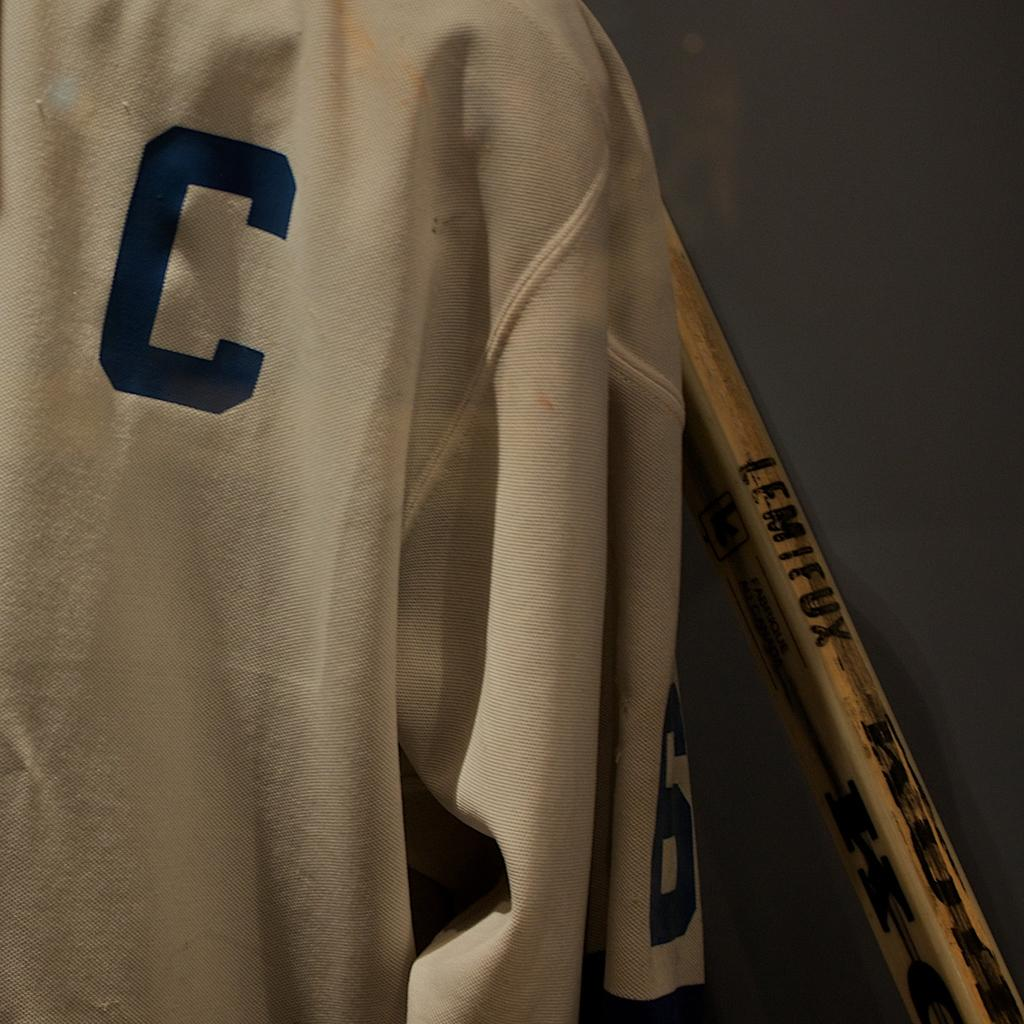Provide a one-sentence caption for the provided image. A WHITE JERSEY WITH INITALS C HANGING BY A LEMIFUX WOODEN BAT. 